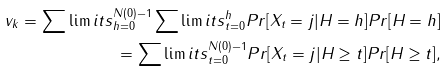<formula> <loc_0><loc_0><loc_500><loc_500>v _ { k } = \sum \lim i t s _ { h = 0 } ^ { N ( 0 ) - 1 } \sum \lim i t s _ { t = 0 } ^ { h } P r [ X _ { t } = j | H = h ] P r [ H = h ] \\ = \sum \lim i t s _ { t = 0 } ^ { N ( 0 ) - 1 } P r [ X _ { t } = j | H \geq t ] P r [ H \geq t ] ,</formula> 